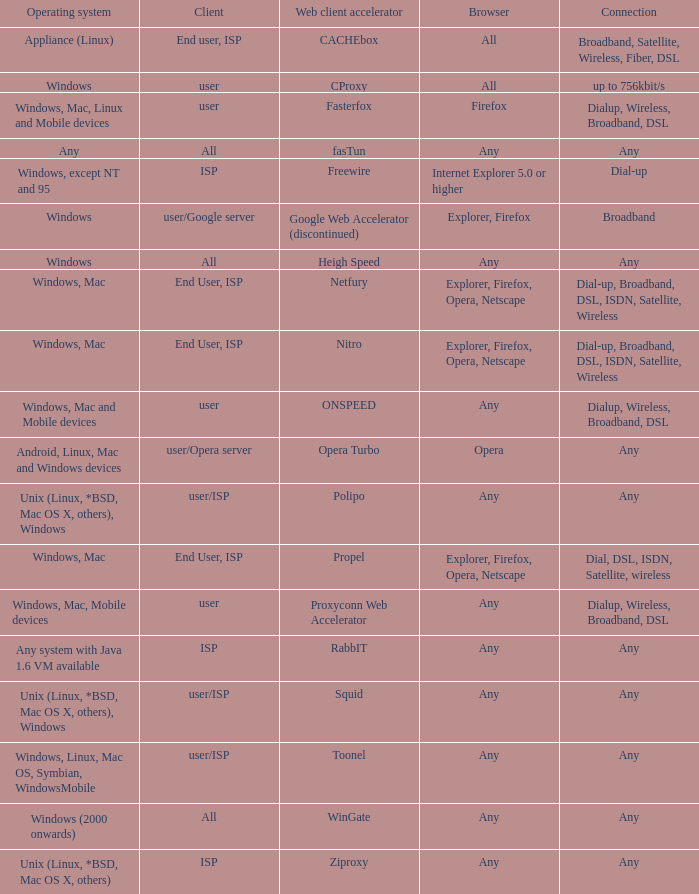What is the connection for the proxyconn web accelerator web client accelerator? Dialup, Wireless, Broadband, DSL. 